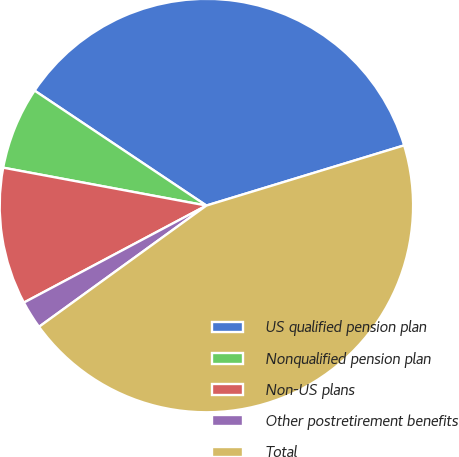<chart> <loc_0><loc_0><loc_500><loc_500><pie_chart><fcel>US qualified pension plan<fcel>Nonqualified pension plan<fcel>Non-US plans<fcel>Other postretirement benefits<fcel>Total<nl><fcel>35.91%<fcel>6.45%<fcel>10.71%<fcel>2.2%<fcel>44.72%<nl></chart> 